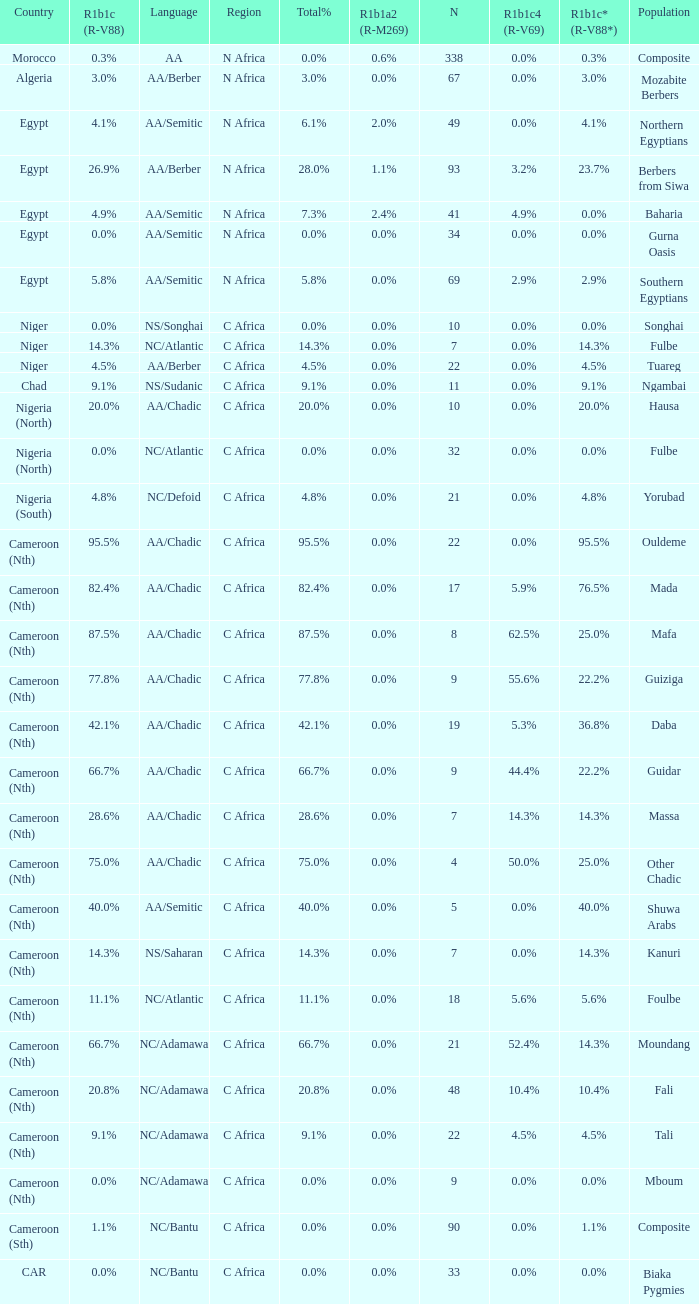How many n are listed for berbers from siwa? 1.0. 